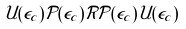Convert formula to latex. <formula><loc_0><loc_0><loc_500><loc_500>\mathcal { U } ( \epsilon _ { c } ) \mathcal { P } ( \epsilon _ { c } ) \mathcal { R } \mathcal { P } ( \epsilon _ { c } ) \mathcal { U } ( \epsilon _ { c } )</formula> 